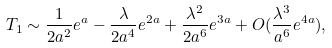<formula> <loc_0><loc_0><loc_500><loc_500>T _ { 1 } \sim \frac { 1 } { 2 a ^ { 2 } } e ^ { a } - \frac { \lambda } { 2 a ^ { 4 } } e ^ { 2 a } + \frac { \lambda ^ { 2 } } { 2 a ^ { 6 } } e ^ { 3 a } + O ( \frac { \lambda ^ { 3 } } { a ^ { 6 } } e ^ { 4 a } ) ,</formula> 